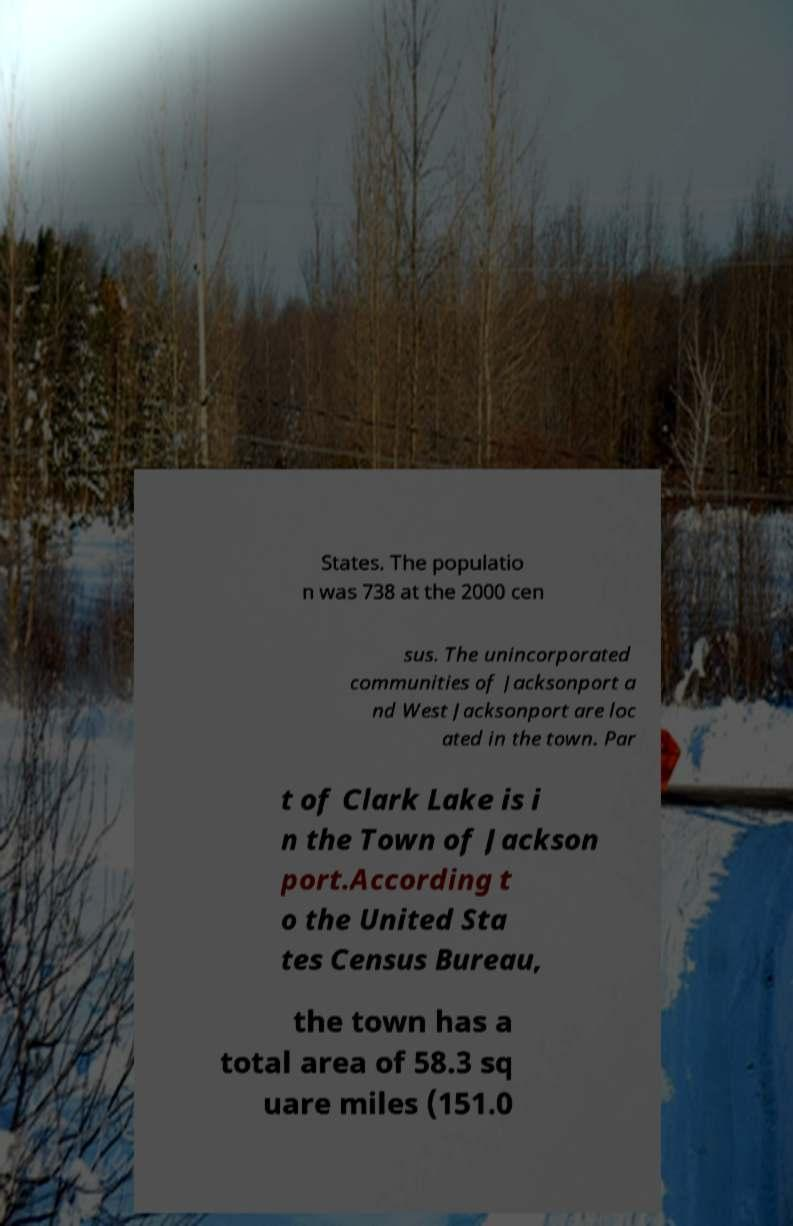Can you read and provide the text displayed in the image?This photo seems to have some interesting text. Can you extract and type it out for me? States. The populatio n was 738 at the 2000 cen sus. The unincorporated communities of Jacksonport a nd West Jacksonport are loc ated in the town. Par t of Clark Lake is i n the Town of Jackson port.According t o the United Sta tes Census Bureau, the town has a total area of 58.3 sq uare miles (151.0 